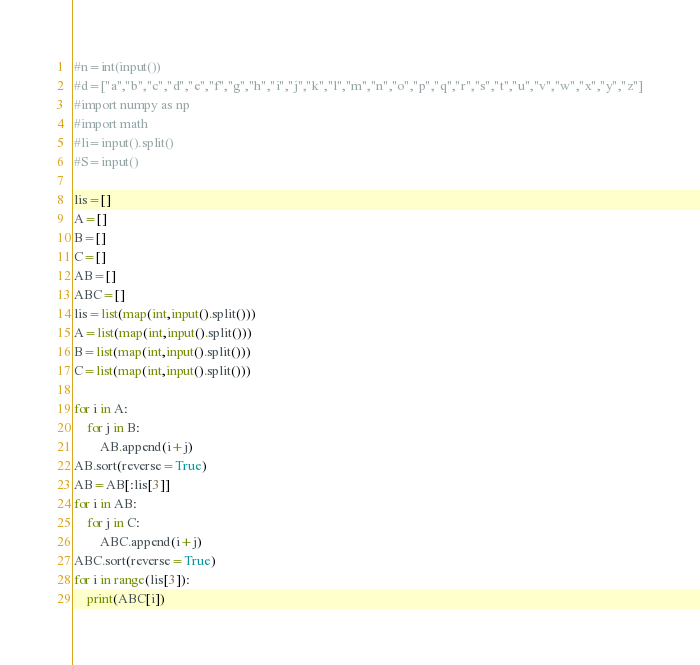<code> <loc_0><loc_0><loc_500><loc_500><_Python_>#n=int(input())
#d=["a","b","c","d","e","f","g","h","i","j","k","l","m","n","o","p","q","r","s","t","u","v","w","x","y","z"]
#import numpy as np
#import math
#li=input().split()
#S=input()

lis=[]
A=[]
B=[]
C=[]
AB=[]
ABC=[]
lis=list(map(int,input().split()))
A=list(map(int,input().split()))
B=list(map(int,input().split()))
C=list(map(int,input().split()))

for i in A:
    for j in B:
        AB.append(i+j)
AB.sort(reverse=True)
AB=AB[:lis[3]]
for i in AB:
    for j in C:
        ABC.append(i+j)
ABC.sort(reverse=True)
for i in range(lis[3]):
    print(ABC[i])
</code> 